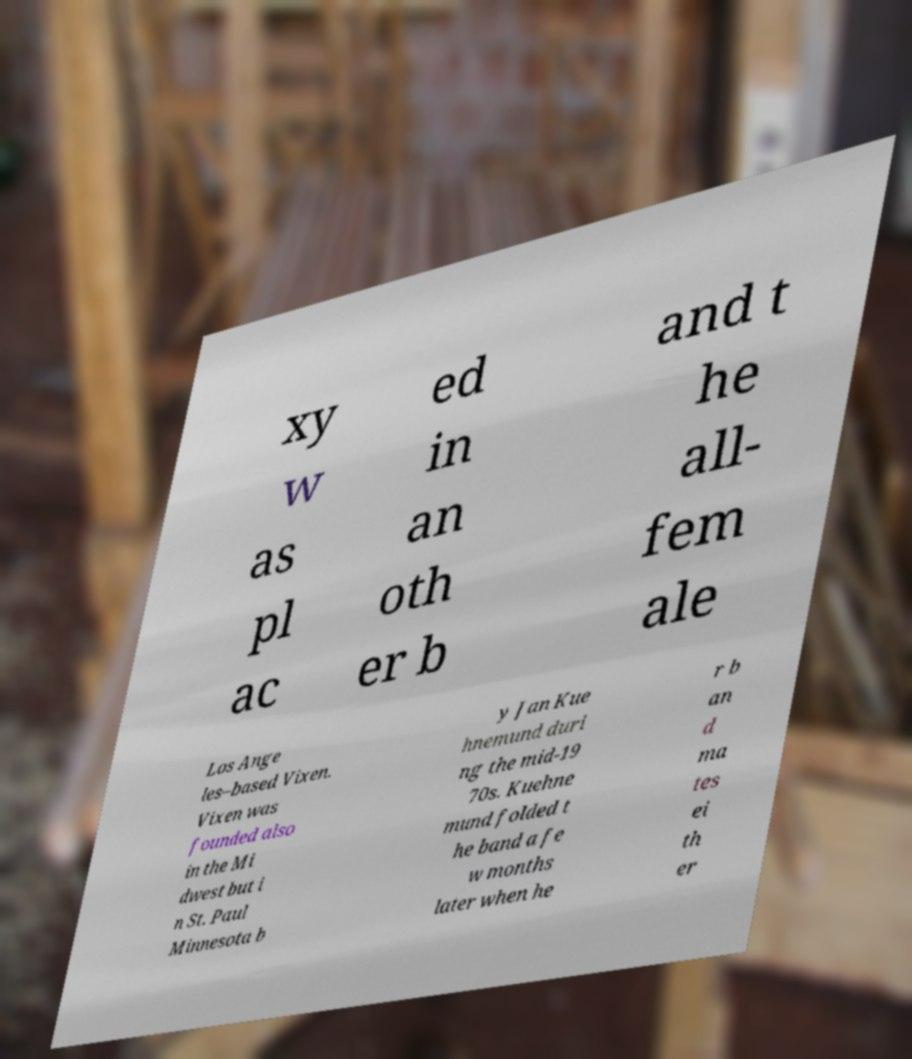Can you accurately transcribe the text from the provided image for me? xy w as pl ac ed in an oth er b and t he all- fem ale Los Ange les–based Vixen. Vixen was founded also in the Mi dwest but i n St. Paul Minnesota b y Jan Kue hnemund duri ng the mid-19 70s. Kuehne mund folded t he band a fe w months later when he r b an d ma tes ei th er 